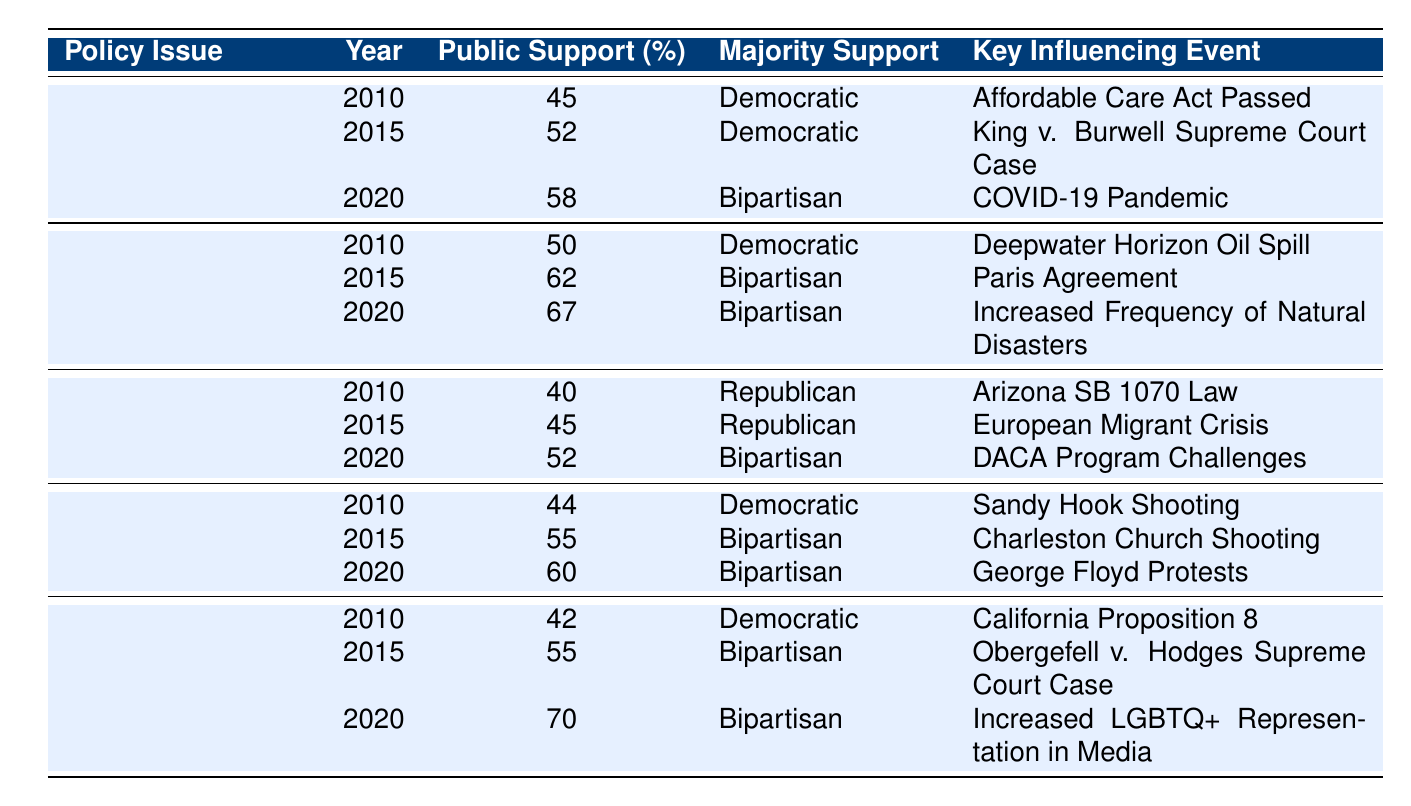What was the public support percentage for Gun Control in 2015? The table shows that for Gun Control in 2015, the public support percentage is 55%.
Answer: 55% Which policy issue had the highest public support in 2020? The table indicates that Same-Sex Marriage had the highest public support in 2020 at 70%.
Answer: Same-Sex Marriage What is the average public support percentage for Immigration Policy from 2010 to 2020? To find the average, add the values for Immigration Policy across the years: (40 + 45 + 52) = 137. Then divide by the number of years, which is 3, resulting in an average of 137/3 = 45.67.
Answer: Approximately 45.67% Did public support for Healthcare Reform increase or decrease from 2010 to 2020? The public support for Healthcare Reform rose from 45% in 2010 to 58% in 2020, indicating an increase.
Answer: Increase Which policy issue had bipartisan majority support in 2020? The table shows that in 2020, both Healthcare Reform, Climate Change, Immigration Policy, Gun Control, and Same-Sex Marriage had bipartisan majority support.
Answer: Healthcare Reform, Climate Change, Immigration Policy, Gun Control, Same-Sex Marriage What was the key influencing event for Same-Sex Marriage in 2015? The table lists the key influencing event for Same-Sex Marriage in 2015 as the Obergefell v. Hodges Supreme Court Case.
Answer: Obergefell v. Hodges Supreme Court Case In which year did the public support for Climate Change first reach bipartisan majority? The percent support for Climate Change reached bipartisan majority in 2015, rising from 50% in 2010 to 62% shortly thereafter.
Answer: 2015 How much did public support for Gun Control increase from 2010 to 2020? Public support for Gun Control rose from 44% in 2010 to 60% in 2020, showing an increase of 16%.
Answer: 16% Was there a majority support change for Immigration Policy between 2015 and 2020? In 2015, the majority support for Immigration Policy was Republican, and by 2020, it shifted to bipartisan. Therefore, there was a change in majority support.
Answer: Yes Which policy issue consistently had Democratic majority support from 2010 to 2015? The data shows that Healthcare Reform and Gun Control consistently had Democratic majority support during 2010 and 2015.
Answer: Healthcare Reform and Gun Control 